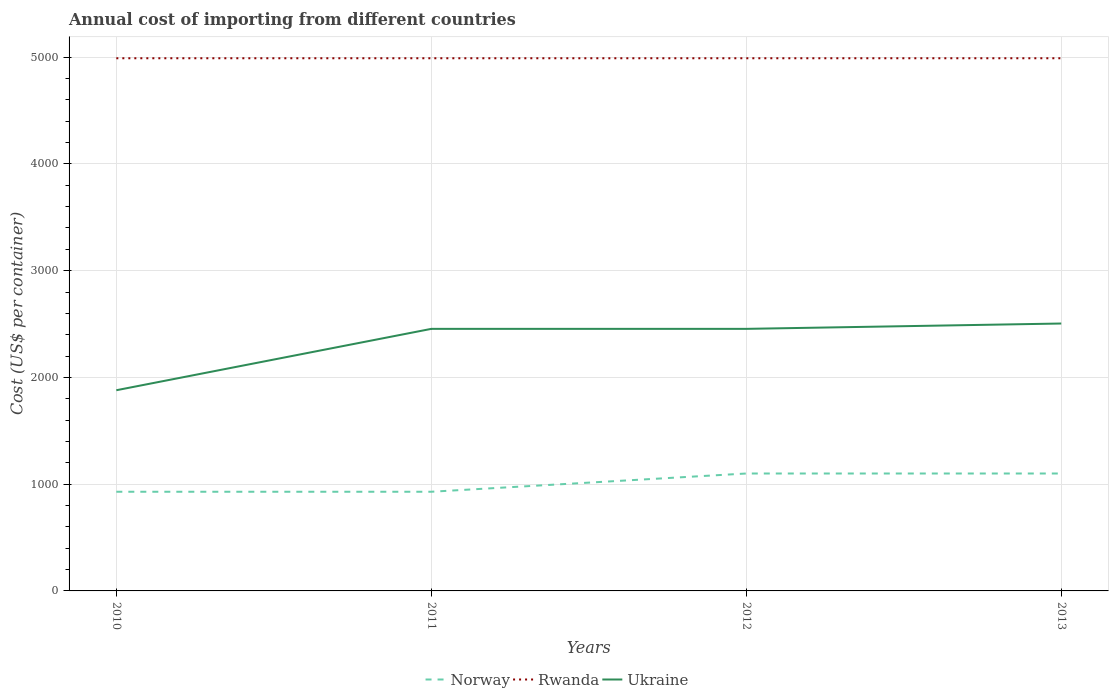Is the number of lines equal to the number of legend labels?
Provide a short and direct response. Yes. Across all years, what is the maximum total annual cost of importing in Ukraine?
Ensure brevity in your answer.  1880. What is the total total annual cost of importing in Rwanda in the graph?
Make the answer very short. 0. What is the difference between the highest and the second highest total annual cost of importing in Rwanda?
Provide a succinct answer. 0. What is the difference between the highest and the lowest total annual cost of importing in Ukraine?
Your response must be concise. 3. Is the total annual cost of importing in Norway strictly greater than the total annual cost of importing in Ukraine over the years?
Provide a succinct answer. Yes. How many lines are there?
Your answer should be compact. 3. How many years are there in the graph?
Your answer should be very brief. 4. Are the values on the major ticks of Y-axis written in scientific E-notation?
Your answer should be compact. No. Does the graph contain any zero values?
Your answer should be compact. No. Where does the legend appear in the graph?
Provide a succinct answer. Bottom center. What is the title of the graph?
Keep it short and to the point. Annual cost of importing from different countries. Does "Guyana" appear as one of the legend labels in the graph?
Ensure brevity in your answer.  No. What is the label or title of the X-axis?
Your answer should be compact. Years. What is the label or title of the Y-axis?
Make the answer very short. Cost (US$ per container). What is the Cost (US$ per container) in Norway in 2010?
Offer a very short reply. 929. What is the Cost (US$ per container) in Rwanda in 2010?
Ensure brevity in your answer.  4990. What is the Cost (US$ per container) in Ukraine in 2010?
Your response must be concise. 1880. What is the Cost (US$ per container) in Norway in 2011?
Give a very brief answer. 929. What is the Cost (US$ per container) of Rwanda in 2011?
Offer a terse response. 4990. What is the Cost (US$ per container) in Ukraine in 2011?
Your answer should be compact. 2455. What is the Cost (US$ per container) in Norway in 2012?
Provide a succinct answer. 1100. What is the Cost (US$ per container) in Rwanda in 2012?
Your answer should be compact. 4990. What is the Cost (US$ per container) of Ukraine in 2012?
Give a very brief answer. 2455. What is the Cost (US$ per container) of Norway in 2013?
Make the answer very short. 1100. What is the Cost (US$ per container) of Rwanda in 2013?
Ensure brevity in your answer.  4990. What is the Cost (US$ per container) of Ukraine in 2013?
Make the answer very short. 2505. Across all years, what is the maximum Cost (US$ per container) of Norway?
Your answer should be very brief. 1100. Across all years, what is the maximum Cost (US$ per container) in Rwanda?
Give a very brief answer. 4990. Across all years, what is the maximum Cost (US$ per container) of Ukraine?
Your answer should be very brief. 2505. Across all years, what is the minimum Cost (US$ per container) of Norway?
Your answer should be compact. 929. Across all years, what is the minimum Cost (US$ per container) in Rwanda?
Ensure brevity in your answer.  4990. Across all years, what is the minimum Cost (US$ per container) of Ukraine?
Provide a succinct answer. 1880. What is the total Cost (US$ per container) of Norway in the graph?
Your answer should be compact. 4058. What is the total Cost (US$ per container) in Rwanda in the graph?
Make the answer very short. 2.00e+04. What is the total Cost (US$ per container) in Ukraine in the graph?
Provide a short and direct response. 9295. What is the difference between the Cost (US$ per container) of Norway in 2010 and that in 2011?
Your response must be concise. 0. What is the difference between the Cost (US$ per container) in Ukraine in 2010 and that in 2011?
Provide a succinct answer. -575. What is the difference between the Cost (US$ per container) of Norway in 2010 and that in 2012?
Your answer should be very brief. -171. What is the difference between the Cost (US$ per container) of Rwanda in 2010 and that in 2012?
Your answer should be compact. 0. What is the difference between the Cost (US$ per container) in Ukraine in 2010 and that in 2012?
Provide a short and direct response. -575. What is the difference between the Cost (US$ per container) of Norway in 2010 and that in 2013?
Keep it short and to the point. -171. What is the difference between the Cost (US$ per container) in Ukraine in 2010 and that in 2013?
Your response must be concise. -625. What is the difference between the Cost (US$ per container) of Norway in 2011 and that in 2012?
Ensure brevity in your answer.  -171. What is the difference between the Cost (US$ per container) of Rwanda in 2011 and that in 2012?
Ensure brevity in your answer.  0. What is the difference between the Cost (US$ per container) in Norway in 2011 and that in 2013?
Your answer should be compact. -171. What is the difference between the Cost (US$ per container) of Rwanda in 2011 and that in 2013?
Give a very brief answer. 0. What is the difference between the Cost (US$ per container) of Ukraine in 2011 and that in 2013?
Give a very brief answer. -50. What is the difference between the Cost (US$ per container) in Norway in 2012 and that in 2013?
Provide a short and direct response. 0. What is the difference between the Cost (US$ per container) in Norway in 2010 and the Cost (US$ per container) in Rwanda in 2011?
Offer a very short reply. -4061. What is the difference between the Cost (US$ per container) of Norway in 2010 and the Cost (US$ per container) of Ukraine in 2011?
Make the answer very short. -1526. What is the difference between the Cost (US$ per container) in Rwanda in 2010 and the Cost (US$ per container) in Ukraine in 2011?
Your response must be concise. 2535. What is the difference between the Cost (US$ per container) in Norway in 2010 and the Cost (US$ per container) in Rwanda in 2012?
Your answer should be very brief. -4061. What is the difference between the Cost (US$ per container) in Norway in 2010 and the Cost (US$ per container) in Ukraine in 2012?
Your answer should be very brief. -1526. What is the difference between the Cost (US$ per container) of Rwanda in 2010 and the Cost (US$ per container) of Ukraine in 2012?
Your answer should be compact. 2535. What is the difference between the Cost (US$ per container) of Norway in 2010 and the Cost (US$ per container) of Rwanda in 2013?
Keep it short and to the point. -4061. What is the difference between the Cost (US$ per container) of Norway in 2010 and the Cost (US$ per container) of Ukraine in 2013?
Ensure brevity in your answer.  -1576. What is the difference between the Cost (US$ per container) of Rwanda in 2010 and the Cost (US$ per container) of Ukraine in 2013?
Offer a terse response. 2485. What is the difference between the Cost (US$ per container) of Norway in 2011 and the Cost (US$ per container) of Rwanda in 2012?
Give a very brief answer. -4061. What is the difference between the Cost (US$ per container) in Norway in 2011 and the Cost (US$ per container) in Ukraine in 2012?
Offer a very short reply. -1526. What is the difference between the Cost (US$ per container) of Rwanda in 2011 and the Cost (US$ per container) of Ukraine in 2012?
Your answer should be compact. 2535. What is the difference between the Cost (US$ per container) of Norway in 2011 and the Cost (US$ per container) of Rwanda in 2013?
Make the answer very short. -4061. What is the difference between the Cost (US$ per container) of Norway in 2011 and the Cost (US$ per container) of Ukraine in 2013?
Provide a short and direct response. -1576. What is the difference between the Cost (US$ per container) in Rwanda in 2011 and the Cost (US$ per container) in Ukraine in 2013?
Your answer should be very brief. 2485. What is the difference between the Cost (US$ per container) of Norway in 2012 and the Cost (US$ per container) of Rwanda in 2013?
Provide a short and direct response. -3890. What is the difference between the Cost (US$ per container) in Norway in 2012 and the Cost (US$ per container) in Ukraine in 2013?
Provide a succinct answer. -1405. What is the difference between the Cost (US$ per container) in Rwanda in 2012 and the Cost (US$ per container) in Ukraine in 2013?
Offer a terse response. 2485. What is the average Cost (US$ per container) in Norway per year?
Ensure brevity in your answer.  1014.5. What is the average Cost (US$ per container) in Rwanda per year?
Keep it short and to the point. 4990. What is the average Cost (US$ per container) of Ukraine per year?
Give a very brief answer. 2323.75. In the year 2010, what is the difference between the Cost (US$ per container) of Norway and Cost (US$ per container) of Rwanda?
Give a very brief answer. -4061. In the year 2010, what is the difference between the Cost (US$ per container) of Norway and Cost (US$ per container) of Ukraine?
Your answer should be compact. -951. In the year 2010, what is the difference between the Cost (US$ per container) in Rwanda and Cost (US$ per container) in Ukraine?
Your answer should be very brief. 3110. In the year 2011, what is the difference between the Cost (US$ per container) in Norway and Cost (US$ per container) in Rwanda?
Offer a very short reply. -4061. In the year 2011, what is the difference between the Cost (US$ per container) of Norway and Cost (US$ per container) of Ukraine?
Provide a short and direct response. -1526. In the year 2011, what is the difference between the Cost (US$ per container) of Rwanda and Cost (US$ per container) of Ukraine?
Give a very brief answer. 2535. In the year 2012, what is the difference between the Cost (US$ per container) of Norway and Cost (US$ per container) of Rwanda?
Offer a terse response. -3890. In the year 2012, what is the difference between the Cost (US$ per container) in Norway and Cost (US$ per container) in Ukraine?
Ensure brevity in your answer.  -1355. In the year 2012, what is the difference between the Cost (US$ per container) in Rwanda and Cost (US$ per container) in Ukraine?
Offer a very short reply. 2535. In the year 2013, what is the difference between the Cost (US$ per container) in Norway and Cost (US$ per container) in Rwanda?
Your answer should be compact. -3890. In the year 2013, what is the difference between the Cost (US$ per container) of Norway and Cost (US$ per container) of Ukraine?
Give a very brief answer. -1405. In the year 2013, what is the difference between the Cost (US$ per container) of Rwanda and Cost (US$ per container) of Ukraine?
Keep it short and to the point. 2485. What is the ratio of the Cost (US$ per container) of Ukraine in 2010 to that in 2011?
Offer a very short reply. 0.77. What is the ratio of the Cost (US$ per container) in Norway in 2010 to that in 2012?
Offer a terse response. 0.84. What is the ratio of the Cost (US$ per container) in Ukraine in 2010 to that in 2012?
Offer a terse response. 0.77. What is the ratio of the Cost (US$ per container) of Norway in 2010 to that in 2013?
Your response must be concise. 0.84. What is the ratio of the Cost (US$ per container) of Rwanda in 2010 to that in 2013?
Give a very brief answer. 1. What is the ratio of the Cost (US$ per container) in Ukraine in 2010 to that in 2013?
Make the answer very short. 0.75. What is the ratio of the Cost (US$ per container) of Norway in 2011 to that in 2012?
Provide a short and direct response. 0.84. What is the ratio of the Cost (US$ per container) in Ukraine in 2011 to that in 2012?
Offer a terse response. 1. What is the ratio of the Cost (US$ per container) of Norway in 2011 to that in 2013?
Provide a short and direct response. 0.84. What is the ratio of the Cost (US$ per container) of Ukraine in 2011 to that in 2013?
Keep it short and to the point. 0.98. What is the ratio of the Cost (US$ per container) in Norway in 2012 to that in 2013?
Ensure brevity in your answer.  1. What is the ratio of the Cost (US$ per container) in Ukraine in 2012 to that in 2013?
Ensure brevity in your answer.  0.98. What is the difference between the highest and the second highest Cost (US$ per container) in Ukraine?
Ensure brevity in your answer.  50. What is the difference between the highest and the lowest Cost (US$ per container) of Norway?
Provide a succinct answer. 171. What is the difference between the highest and the lowest Cost (US$ per container) in Ukraine?
Your answer should be compact. 625. 